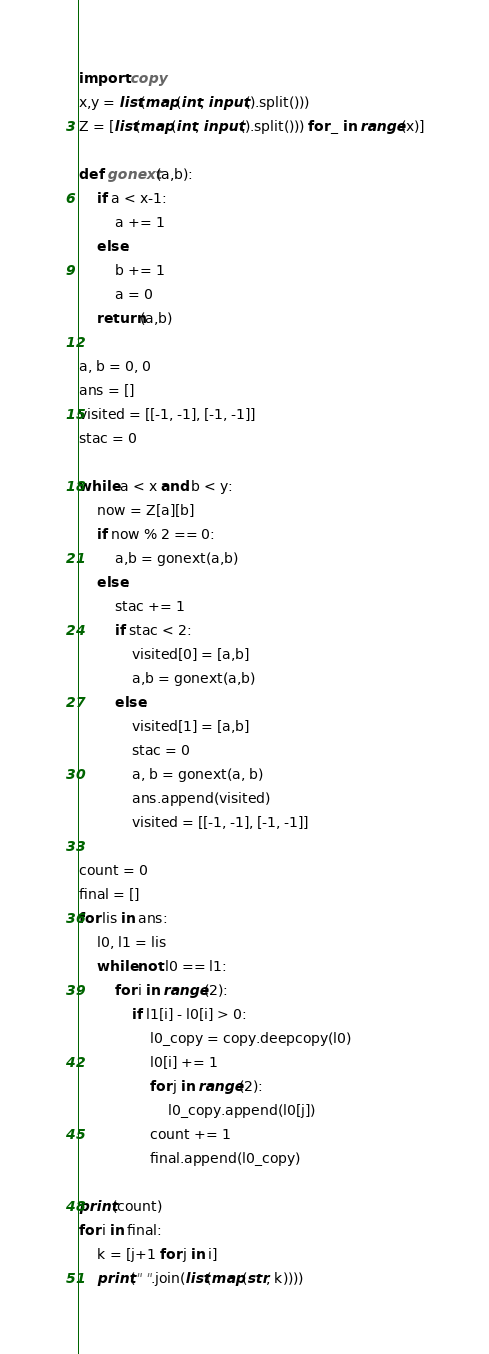<code> <loc_0><loc_0><loc_500><loc_500><_Python_>import copy
x,y = list(map(int, input().split()))
Z = [list(map(int, input().split())) for _ in range(x)]

def gonext(a,b):
    if a < x-1:
        a += 1
    else:
        b += 1
        a = 0
    return(a,b)

a, b = 0, 0
ans = []
visited = [[-1, -1], [-1, -1]]
stac = 0

while a < x and b < y:
    now = Z[a][b]
    if now % 2 == 0:
        a,b = gonext(a,b)
    else:
        stac += 1
        if stac < 2:
            visited[0] = [a,b]
            a,b = gonext(a,b)
        else:
            visited[1] = [a,b]
            stac = 0
            a, b = gonext(a, b)
            ans.append(visited)
            visited = [[-1, -1], [-1, -1]]

count = 0
final = []
for lis in ans:
    l0, l1 = lis
    while not l0 == l1:
        for i in range(2):
            if l1[i] - l0[i] > 0:
                l0_copy = copy.deepcopy(l0)
                l0[i] += 1
                for j in range(2):
                    l0_copy.append(l0[j])
                count += 1
                final.append(l0_copy)

print(count)
for i in final:
    k = [j+1 for j in i]
    print(" ".join(list(map(str, k))))</code> 